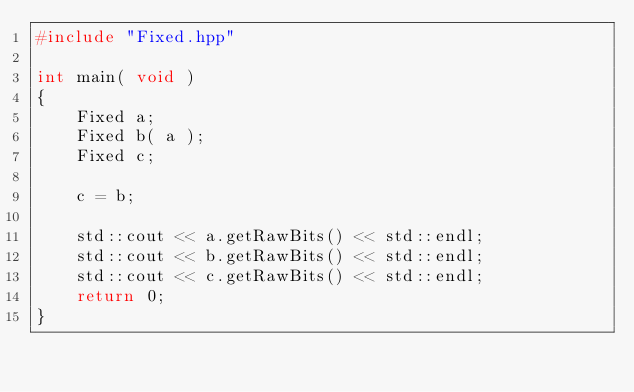Convert code to text. <code><loc_0><loc_0><loc_500><loc_500><_C++_>#include "Fixed.hpp"

int main( void )
{
    Fixed a;
    Fixed b( a );
    Fixed c;

    c = b;

    std::cout << a.getRawBits() << std::endl;
    std::cout << b.getRawBits() << std::endl;
    std::cout << c.getRawBits() << std::endl;
    return 0;
}
</code> 